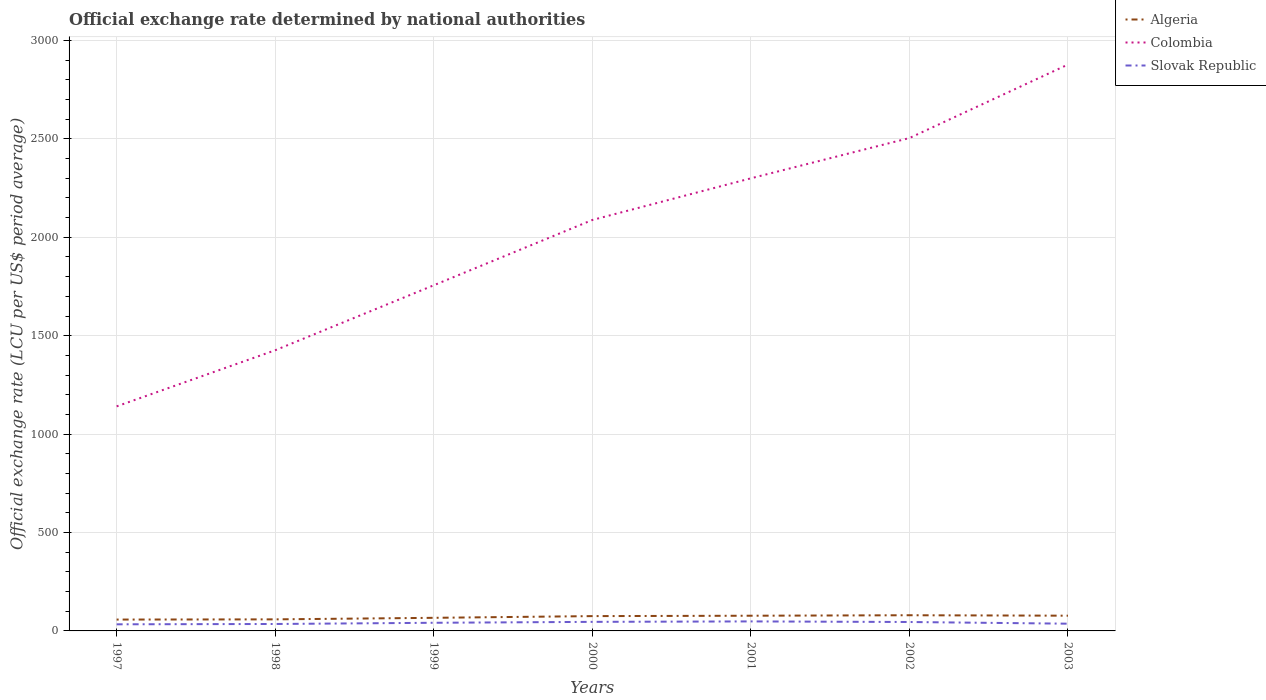Across all years, what is the maximum official exchange rate in Algeria?
Offer a very short reply. 57.71. What is the total official exchange rate in Slovak Republic in the graph?
Make the answer very short. -3.16. What is the difference between the highest and the second highest official exchange rate in Algeria?
Keep it short and to the point. 21.97. What is the difference between the highest and the lowest official exchange rate in Colombia?
Keep it short and to the point. 4. How many lines are there?
Keep it short and to the point. 3. What is the difference between two consecutive major ticks on the Y-axis?
Your response must be concise. 500. Are the values on the major ticks of Y-axis written in scientific E-notation?
Provide a succinct answer. No. Does the graph contain any zero values?
Your answer should be very brief. No. How many legend labels are there?
Offer a very short reply. 3. How are the legend labels stacked?
Make the answer very short. Vertical. What is the title of the graph?
Keep it short and to the point. Official exchange rate determined by national authorities. Does "Dominica" appear as one of the legend labels in the graph?
Offer a terse response. No. What is the label or title of the X-axis?
Your answer should be very brief. Years. What is the label or title of the Y-axis?
Keep it short and to the point. Official exchange rate (LCU per US$ period average). What is the Official exchange rate (LCU per US$ period average) in Algeria in 1997?
Give a very brief answer. 57.71. What is the Official exchange rate (LCU per US$ period average) in Colombia in 1997?
Provide a succinct answer. 1140.96. What is the Official exchange rate (LCU per US$ period average) in Slovak Republic in 1997?
Offer a terse response. 33.62. What is the Official exchange rate (LCU per US$ period average) in Algeria in 1998?
Your answer should be compact. 58.74. What is the Official exchange rate (LCU per US$ period average) of Colombia in 1998?
Offer a terse response. 1426.04. What is the Official exchange rate (LCU per US$ period average) of Slovak Republic in 1998?
Keep it short and to the point. 35.23. What is the Official exchange rate (LCU per US$ period average) of Algeria in 1999?
Your response must be concise. 66.57. What is the Official exchange rate (LCU per US$ period average) in Colombia in 1999?
Offer a very short reply. 1756.23. What is the Official exchange rate (LCU per US$ period average) of Slovak Republic in 1999?
Give a very brief answer. 41.36. What is the Official exchange rate (LCU per US$ period average) in Algeria in 2000?
Provide a short and direct response. 75.26. What is the Official exchange rate (LCU per US$ period average) in Colombia in 2000?
Your answer should be very brief. 2087.9. What is the Official exchange rate (LCU per US$ period average) in Slovak Republic in 2000?
Your answer should be very brief. 46.04. What is the Official exchange rate (LCU per US$ period average) in Algeria in 2001?
Ensure brevity in your answer.  77.22. What is the Official exchange rate (LCU per US$ period average) of Colombia in 2001?
Your answer should be compact. 2299.63. What is the Official exchange rate (LCU per US$ period average) of Slovak Republic in 2001?
Your response must be concise. 48.35. What is the Official exchange rate (LCU per US$ period average) of Algeria in 2002?
Make the answer very short. 79.68. What is the Official exchange rate (LCU per US$ period average) in Colombia in 2002?
Provide a short and direct response. 2504.24. What is the Official exchange rate (LCU per US$ period average) of Slovak Republic in 2002?
Make the answer very short. 45.33. What is the Official exchange rate (LCU per US$ period average) of Algeria in 2003?
Offer a very short reply. 77.39. What is the Official exchange rate (LCU per US$ period average) of Colombia in 2003?
Provide a short and direct response. 2877.65. What is the Official exchange rate (LCU per US$ period average) of Slovak Republic in 2003?
Keep it short and to the point. 36.77. Across all years, what is the maximum Official exchange rate (LCU per US$ period average) in Algeria?
Your answer should be very brief. 79.68. Across all years, what is the maximum Official exchange rate (LCU per US$ period average) in Colombia?
Provide a short and direct response. 2877.65. Across all years, what is the maximum Official exchange rate (LCU per US$ period average) in Slovak Republic?
Provide a succinct answer. 48.35. Across all years, what is the minimum Official exchange rate (LCU per US$ period average) of Algeria?
Make the answer very short. 57.71. Across all years, what is the minimum Official exchange rate (LCU per US$ period average) in Colombia?
Offer a very short reply. 1140.96. Across all years, what is the minimum Official exchange rate (LCU per US$ period average) of Slovak Republic?
Your answer should be very brief. 33.62. What is the total Official exchange rate (LCU per US$ period average) in Algeria in the graph?
Offer a terse response. 492.57. What is the total Official exchange rate (LCU per US$ period average) in Colombia in the graph?
Ensure brevity in your answer.  1.41e+04. What is the total Official exchange rate (LCU per US$ period average) in Slovak Republic in the graph?
Offer a terse response. 286.7. What is the difference between the Official exchange rate (LCU per US$ period average) of Algeria in 1997 and that in 1998?
Your answer should be very brief. -1.03. What is the difference between the Official exchange rate (LCU per US$ period average) of Colombia in 1997 and that in 1998?
Provide a succinct answer. -285.07. What is the difference between the Official exchange rate (LCU per US$ period average) in Slovak Republic in 1997 and that in 1998?
Ensure brevity in your answer.  -1.62. What is the difference between the Official exchange rate (LCU per US$ period average) in Algeria in 1997 and that in 1999?
Make the answer very short. -8.87. What is the difference between the Official exchange rate (LCU per US$ period average) in Colombia in 1997 and that in 1999?
Your answer should be compact. -615.27. What is the difference between the Official exchange rate (LCU per US$ period average) of Slovak Republic in 1997 and that in 1999?
Provide a succinct answer. -7.75. What is the difference between the Official exchange rate (LCU per US$ period average) of Algeria in 1997 and that in 2000?
Offer a very short reply. -17.55. What is the difference between the Official exchange rate (LCU per US$ period average) in Colombia in 1997 and that in 2000?
Your answer should be compact. -946.94. What is the difference between the Official exchange rate (LCU per US$ period average) of Slovak Republic in 1997 and that in 2000?
Keep it short and to the point. -12.42. What is the difference between the Official exchange rate (LCU per US$ period average) in Algeria in 1997 and that in 2001?
Your answer should be compact. -19.51. What is the difference between the Official exchange rate (LCU per US$ period average) of Colombia in 1997 and that in 2001?
Keep it short and to the point. -1158.67. What is the difference between the Official exchange rate (LCU per US$ period average) of Slovak Republic in 1997 and that in 2001?
Offer a very short reply. -14.74. What is the difference between the Official exchange rate (LCU per US$ period average) in Algeria in 1997 and that in 2002?
Offer a very short reply. -21.97. What is the difference between the Official exchange rate (LCU per US$ period average) in Colombia in 1997 and that in 2002?
Your response must be concise. -1363.28. What is the difference between the Official exchange rate (LCU per US$ period average) of Slovak Republic in 1997 and that in 2002?
Your answer should be very brief. -11.71. What is the difference between the Official exchange rate (LCU per US$ period average) of Algeria in 1997 and that in 2003?
Your response must be concise. -19.69. What is the difference between the Official exchange rate (LCU per US$ period average) of Colombia in 1997 and that in 2003?
Offer a very short reply. -1736.69. What is the difference between the Official exchange rate (LCU per US$ period average) in Slovak Republic in 1997 and that in 2003?
Your answer should be compact. -3.16. What is the difference between the Official exchange rate (LCU per US$ period average) of Algeria in 1998 and that in 1999?
Keep it short and to the point. -7.83. What is the difference between the Official exchange rate (LCU per US$ period average) of Colombia in 1998 and that in 1999?
Keep it short and to the point. -330.19. What is the difference between the Official exchange rate (LCU per US$ period average) in Slovak Republic in 1998 and that in 1999?
Give a very brief answer. -6.13. What is the difference between the Official exchange rate (LCU per US$ period average) of Algeria in 1998 and that in 2000?
Your answer should be compact. -16.52. What is the difference between the Official exchange rate (LCU per US$ period average) in Colombia in 1998 and that in 2000?
Offer a terse response. -661.87. What is the difference between the Official exchange rate (LCU per US$ period average) of Slovak Republic in 1998 and that in 2000?
Keep it short and to the point. -10.8. What is the difference between the Official exchange rate (LCU per US$ period average) of Algeria in 1998 and that in 2001?
Keep it short and to the point. -18.48. What is the difference between the Official exchange rate (LCU per US$ period average) of Colombia in 1998 and that in 2001?
Provide a succinct answer. -873.6. What is the difference between the Official exchange rate (LCU per US$ period average) of Slovak Republic in 1998 and that in 2001?
Your answer should be compact. -13.12. What is the difference between the Official exchange rate (LCU per US$ period average) of Algeria in 1998 and that in 2002?
Offer a terse response. -20.94. What is the difference between the Official exchange rate (LCU per US$ period average) in Colombia in 1998 and that in 2002?
Offer a terse response. -1078.2. What is the difference between the Official exchange rate (LCU per US$ period average) of Slovak Republic in 1998 and that in 2002?
Your answer should be very brief. -10.09. What is the difference between the Official exchange rate (LCU per US$ period average) of Algeria in 1998 and that in 2003?
Provide a succinct answer. -18.66. What is the difference between the Official exchange rate (LCU per US$ period average) of Colombia in 1998 and that in 2003?
Ensure brevity in your answer.  -1451.62. What is the difference between the Official exchange rate (LCU per US$ period average) of Slovak Republic in 1998 and that in 2003?
Make the answer very short. -1.54. What is the difference between the Official exchange rate (LCU per US$ period average) in Algeria in 1999 and that in 2000?
Offer a terse response. -8.69. What is the difference between the Official exchange rate (LCU per US$ period average) of Colombia in 1999 and that in 2000?
Provide a short and direct response. -331.67. What is the difference between the Official exchange rate (LCU per US$ period average) in Slovak Republic in 1999 and that in 2000?
Your answer should be very brief. -4.67. What is the difference between the Official exchange rate (LCU per US$ period average) of Algeria in 1999 and that in 2001?
Provide a short and direct response. -10.64. What is the difference between the Official exchange rate (LCU per US$ period average) of Colombia in 1999 and that in 2001?
Make the answer very short. -543.4. What is the difference between the Official exchange rate (LCU per US$ period average) of Slovak Republic in 1999 and that in 2001?
Provide a succinct answer. -6.99. What is the difference between the Official exchange rate (LCU per US$ period average) in Algeria in 1999 and that in 2002?
Ensure brevity in your answer.  -13.11. What is the difference between the Official exchange rate (LCU per US$ period average) of Colombia in 1999 and that in 2002?
Your answer should be very brief. -748.01. What is the difference between the Official exchange rate (LCU per US$ period average) in Slovak Republic in 1999 and that in 2002?
Offer a very short reply. -3.96. What is the difference between the Official exchange rate (LCU per US$ period average) of Algeria in 1999 and that in 2003?
Your answer should be very brief. -10.82. What is the difference between the Official exchange rate (LCU per US$ period average) of Colombia in 1999 and that in 2003?
Offer a very short reply. -1121.42. What is the difference between the Official exchange rate (LCU per US$ period average) of Slovak Republic in 1999 and that in 2003?
Provide a short and direct response. 4.59. What is the difference between the Official exchange rate (LCU per US$ period average) in Algeria in 2000 and that in 2001?
Make the answer very short. -1.96. What is the difference between the Official exchange rate (LCU per US$ period average) in Colombia in 2000 and that in 2001?
Your response must be concise. -211.73. What is the difference between the Official exchange rate (LCU per US$ period average) of Slovak Republic in 2000 and that in 2001?
Provide a short and direct response. -2.32. What is the difference between the Official exchange rate (LCU per US$ period average) in Algeria in 2000 and that in 2002?
Keep it short and to the point. -4.42. What is the difference between the Official exchange rate (LCU per US$ period average) in Colombia in 2000 and that in 2002?
Give a very brief answer. -416.34. What is the difference between the Official exchange rate (LCU per US$ period average) of Slovak Republic in 2000 and that in 2002?
Your response must be concise. 0.71. What is the difference between the Official exchange rate (LCU per US$ period average) of Algeria in 2000 and that in 2003?
Make the answer very short. -2.14. What is the difference between the Official exchange rate (LCU per US$ period average) in Colombia in 2000 and that in 2003?
Your answer should be compact. -789.75. What is the difference between the Official exchange rate (LCU per US$ period average) in Slovak Republic in 2000 and that in 2003?
Your answer should be compact. 9.26. What is the difference between the Official exchange rate (LCU per US$ period average) in Algeria in 2001 and that in 2002?
Your response must be concise. -2.47. What is the difference between the Official exchange rate (LCU per US$ period average) in Colombia in 2001 and that in 2002?
Provide a succinct answer. -204.61. What is the difference between the Official exchange rate (LCU per US$ period average) in Slovak Republic in 2001 and that in 2002?
Keep it short and to the point. 3.03. What is the difference between the Official exchange rate (LCU per US$ period average) of Algeria in 2001 and that in 2003?
Your response must be concise. -0.18. What is the difference between the Official exchange rate (LCU per US$ period average) in Colombia in 2001 and that in 2003?
Provide a short and direct response. -578.02. What is the difference between the Official exchange rate (LCU per US$ period average) of Slovak Republic in 2001 and that in 2003?
Provide a succinct answer. 11.58. What is the difference between the Official exchange rate (LCU per US$ period average) in Algeria in 2002 and that in 2003?
Your answer should be compact. 2.29. What is the difference between the Official exchange rate (LCU per US$ period average) of Colombia in 2002 and that in 2003?
Keep it short and to the point. -373.41. What is the difference between the Official exchange rate (LCU per US$ period average) of Slovak Republic in 2002 and that in 2003?
Your answer should be very brief. 8.55. What is the difference between the Official exchange rate (LCU per US$ period average) in Algeria in 1997 and the Official exchange rate (LCU per US$ period average) in Colombia in 1998?
Your answer should be compact. -1368.33. What is the difference between the Official exchange rate (LCU per US$ period average) in Algeria in 1997 and the Official exchange rate (LCU per US$ period average) in Slovak Republic in 1998?
Make the answer very short. 22.47. What is the difference between the Official exchange rate (LCU per US$ period average) in Colombia in 1997 and the Official exchange rate (LCU per US$ period average) in Slovak Republic in 1998?
Provide a short and direct response. 1105.73. What is the difference between the Official exchange rate (LCU per US$ period average) in Algeria in 1997 and the Official exchange rate (LCU per US$ period average) in Colombia in 1999?
Make the answer very short. -1698.52. What is the difference between the Official exchange rate (LCU per US$ period average) in Algeria in 1997 and the Official exchange rate (LCU per US$ period average) in Slovak Republic in 1999?
Ensure brevity in your answer.  16.34. What is the difference between the Official exchange rate (LCU per US$ period average) in Colombia in 1997 and the Official exchange rate (LCU per US$ period average) in Slovak Republic in 1999?
Ensure brevity in your answer.  1099.6. What is the difference between the Official exchange rate (LCU per US$ period average) of Algeria in 1997 and the Official exchange rate (LCU per US$ period average) of Colombia in 2000?
Your response must be concise. -2030.2. What is the difference between the Official exchange rate (LCU per US$ period average) of Algeria in 1997 and the Official exchange rate (LCU per US$ period average) of Slovak Republic in 2000?
Offer a very short reply. 11.67. What is the difference between the Official exchange rate (LCU per US$ period average) in Colombia in 1997 and the Official exchange rate (LCU per US$ period average) in Slovak Republic in 2000?
Your answer should be very brief. 1094.93. What is the difference between the Official exchange rate (LCU per US$ period average) in Algeria in 1997 and the Official exchange rate (LCU per US$ period average) in Colombia in 2001?
Provide a short and direct response. -2241.93. What is the difference between the Official exchange rate (LCU per US$ period average) of Algeria in 1997 and the Official exchange rate (LCU per US$ period average) of Slovak Republic in 2001?
Make the answer very short. 9.35. What is the difference between the Official exchange rate (LCU per US$ period average) in Colombia in 1997 and the Official exchange rate (LCU per US$ period average) in Slovak Republic in 2001?
Offer a very short reply. 1092.61. What is the difference between the Official exchange rate (LCU per US$ period average) of Algeria in 1997 and the Official exchange rate (LCU per US$ period average) of Colombia in 2002?
Give a very brief answer. -2446.53. What is the difference between the Official exchange rate (LCU per US$ period average) of Algeria in 1997 and the Official exchange rate (LCU per US$ period average) of Slovak Republic in 2002?
Ensure brevity in your answer.  12.38. What is the difference between the Official exchange rate (LCU per US$ period average) in Colombia in 1997 and the Official exchange rate (LCU per US$ period average) in Slovak Republic in 2002?
Your answer should be very brief. 1095.64. What is the difference between the Official exchange rate (LCU per US$ period average) in Algeria in 1997 and the Official exchange rate (LCU per US$ period average) in Colombia in 2003?
Give a very brief answer. -2819.95. What is the difference between the Official exchange rate (LCU per US$ period average) of Algeria in 1997 and the Official exchange rate (LCU per US$ period average) of Slovak Republic in 2003?
Offer a terse response. 20.93. What is the difference between the Official exchange rate (LCU per US$ period average) of Colombia in 1997 and the Official exchange rate (LCU per US$ period average) of Slovak Republic in 2003?
Your answer should be compact. 1104.19. What is the difference between the Official exchange rate (LCU per US$ period average) in Algeria in 1998 and the Official exchange rate (LCU per US$ period average) in Colombia in 1999?
Your answer should be compact. -1697.49. What is the difference between the Official exchange rate (LCU per US$ period average) in Algeria in 1998 and the Official exchange rate (LCU per US$ period average) in Slovak Republic in 1999?
Ensure brevity in your answer.  17.38. What is the difference between the Official exchange rate (LCU per US$ period average) in Colombia in 1998 and the Official exchange rate (LCU per US$ period average) in Slovak Republic in 1999?
Your answer should be compact. 1384.67. What is the difference between the Official exchange rate (LCU per US$ period average) in Algeria in 1998 and the Official exchange rate (LCU per US$ period average) in Colombia in 2000?
Make the answer very short. -2029.16. What is the difference between the Official exchange rate (LCU per US$ period average) in Algeria in 1998 and the Official exchange rate (LCU per US$ period average) in Slovak Republic in 2000?
Ensure brevity in your answer.  12.7. What is the difference between the Official exchange rate (LCU per US$ period average) in Colombia in 1998 and the Official exchange rate (LCU per US$ period average) in Slovak Republic in 2000?
Offer a very short reply. 1380. What is the difference between the Official exchange rate (LCU per US$ period average) of Algeria in 1998 and the Official exchange rate (LCU per US$ period average) of Colombia in 2001?
Provide a succinct answer. -2240.89. What is the difference between the Official exchange rate (LCU per US$ period average) in Algeria in 1998 and the Official exchange rate (LCU per US$ period average) in Slovak Republic in 2001?
Ensure brevity in your answer.  10.38. What is the difference between the Official exchange rate (LCU per US$ period average) in Colombia in 1998 and the Official exchange rate (LCU per US$ period average) in Slovak Republic in 2001?
Provide a short and direct response. 1377.68. What is the difference between the Official exchange rate (LCU per US$ period average) of Algeria in 1998 and the Official exchange rate (LCU per US$ period average) of Colombia in 2002?
Provide a succinct answer. -2445.5. What is the difference between the Official exchange rate (LCU per US$ period average) of Algeria in 1998 and the Official exchange rate (LCU per US$ period average) of Slovak Republic in 2002?
Offer a terse response. 13.41. What is the difference between the Official exchange rate (LCU per US$ period average) of Colombia in 1998 and the Official exchange rate (LCU per US$ period average) of Slovak Republic in 2002?
Offer a terse response. 1380.71. What is the difference between the Official exchange rate (LCU per US$ period average) in Algeria in 1998 and the Official exchange rate (LCU per US$ period average) in Colombia in 2003?
Give a very brief answer. -2818.91. What is the difference between the Official exchange rate (LCU per US$ period average) in Algeria in 1998 and the Official exchange rate (LCU per US$ period average) in Slovak Republic in 2003?
Your answer should be compact. 21.97. What is the difference between the Official exchange rate (LCU per US$ period average) in Colombia in 1998 and the Official exchange rate (LCU per US$ period average) in Slovak Republic in 2003?
Make the answer very short. 1389.26. What is the difference between the Official exchange rate (LCU per US$ period average) in Algeria in 1999 and the Official exchange rate (LCU per US$ period average) in Colombia in 2000?
Offer a terse response. -2021.33. What is the difference between the Official exchange rate (LCU per US$ period average) of Algeria in 1999 and the Official exchange rate (LCU per US$ period average) of Slovak Republic in 2000?
Your answer should be very brief. 20.54. What is the difference between the Official exchange rate (LCU per US$ period average) of Colombia in 1999 and the Official exchange rate (LCU per US$ period average) of Slovak Republic in 2000?
Provide a short and direct response. 1710.2. What is the difference between the Official exchange rate (LCU per US$ period average) in Algeria in 1999 and the Official exchange rate (LCU per US$ period average) in Colombia in 2001?
Keep it short and to the point. -2233.06. What is the difference between the Official exchange rate (LCU per US$ period average) in Algeria in 1999 and the Official exchange rate (LCU per US$ period average) in Slovak Republic in 2001?
Keep it short and to the point. 18.22. What is the difference between the Official exchange rate (LCU per US$ period average) of Colombia in 1999 and the Official exchange rate (LCU per US$ period average) of Slovak Republic in 2001?
Keep it short and to the point. 1707.88. What is the difference between the Official exchange rate (LCU per US$ period average) in Algeria in 1999 and the Official exchange rate (LCU per US$ period average) in Colombia in 2002?
Your answer should be very brief. -2437.67. What is the difference between the Official exchange rate (LCU per US$ period average) in Algeria in 1999 and the Official exchange rate (LCU per US$ period average) in Slovak Republic in 2002?
Your response must be concise. 21.25. What is the difference between the Official exchange rate (LCU per US$ period average) of Colombia in 1999 and the Official exchange rate (LCU per US$ period average) of Slovak Republic in 2002?
Your answer should be very brief. 1710.9. What is the difference between the Official exchange rate (LCU per US$ period average) of Algeria in 1999 and the Official exchange rate (LCU per US$ period average) of Colombia in 2003?
Your response must be concise. -2811.08. What is the difference between the Official exchange rate (LCU per US$ period average) in Algeria in 1999 and the Official exchange rate (LCU per US$ period average) in Slovak Republic in 2003?
Ensure brevity in your answer.  29.8. What is the difference between the Official exchange rate (LCU per US$ period average) of Colombia in 1999 and the Official exchange rate (LCU per US$ period average) of Slovak Republic in 2003?
Your response must be concise. 1719.46. What is the difference between the Official exchange rate (LCU per US$ period average) of Algeria in 2000 and the Official exchange rate (LCU per US$ period average) of Colombia in 2001?
Offer a terse response. -2224.37. What is the difference between the Official exchange rate (LCU per US$ period average) of Algeria in 2000 and the Official exchange rate (LCU per US$ period average) of Slovak Republic in 2001?
Keep it short and to the point. 26.91. What is the difference between the Official exchange rate (LCU per US$ period average) of Colombia in 2000 and the Official exchange rate (LCU per US$ period average) of Slovak Republic in 2001?
Provide a succinct answer. 2039.55. What is the difference between the Official exchange rate (LCU per US$ period average) of Algeria in 2000 and the Official exchange rate (LCU per US$ period average) of Colombia in 2002?
Give a very brief answer. -2428.98. What is the difference between the Official exchange rate (LCU per US$ period average) of Algeria in 2000 and the Official exchange rate (LCU per US$ period average) of Slovak Republic in 2002?
Your answer should be very brief. 29.93. What is the difference between the Official exchange rate (LCU per US$ period average) of Colombia in 2000 and the Official exchange rate (LCU per US$ period average) of Slovak Republic in 2002?
Your answer should be compact. 2042.58. What is the difference between the Official exchange rate (LCU per US$ period average) in Algeria in 2000 and the Official exchange rate (LCU per US$ period average) in Colombia in 2003?
Keep it short and to the point. -2802.39. What is the difference between the Official exchange rate (LCU per US$ period average) of Algeria in 2000 and the Official exchange rate (LCU per US$ period average) of Slovak Republic in 2003?
Offer a terse response. 38.49. What is the difference between the Official exchange rate (LCU per US$ period average) in Colombia in 2000 and the Official exchange rate (LCU per US$ period average) in Slovak Republic in 2003?
Your answer should be compact. 2051.13. What is the difference between the Official exchange rate (LCU per US$ period average) in Algeria in 2001 and the Official exchange rate (LCU per US$ period average) in Colombia in 2002?
Offer a terse response. -2427.03. What is the difference between the Official exchange rate (LCU per US$ period average) of Algeria in 2001 and the Official exchange rate (LCU per US$ period average) of Slovak Republic in 2002?
Your answer should be compact. 31.89. What is the difference between the Official exchange rate (LCU per US$ period average) in Colombia in 2001 and the Official exchange rate (LCU per US$ period average) in Slovak Republic in 2002?
Your answer should be compact. 2254.31. What is the difference between the Official exchange rate (LCU per US$ period average) of Algeria in 2001 and the Official exchange rate (LCU per US$ period average) of Colombia in 2003?
Ensure brevity in your answer.  -2800.44. What is the difference between the Official exchange rate (LCU per US$ period average) in Algeria in 2001 and the Official exchange rate (LCU per US$ period average) in Slovak Republic in 2003?
Your answer should be very brief. 40.44. What is the difference between the Official exchange rate (LCU per US$ period average) in Colombia in 2001 and the Official exchange rate (LCU per US$ period average) in Slovak Republic in 2003?
Give a very brief answer. 2262.86. What is the difference between the Official exchange rate (LCU per US$ period average) of Algeria in 2002 and the Official exchange rate (LCU per US$ period average) of Colombia in 2003?
Your answer should be compact. -2797.97. What is the difference between the Official exchange rate (LCU per US$ period average) of Algeria in 2002 and the Official exchange rate (LCU per US$ period average) of Slovak Republic in 2003?
Keep it short and to the point. 42.91. What is the difference between the Official exchange rate (LCU per US$ period average) in Colombia in 2002 and the Official exchange rate (LCU per US$ period average) in Slovak Republic in 2003?
Give a very brief answer. 2467.47. What is the average Official exchange rate (LCU per US$ period average) of Algeria per year?
Your answer should be compact. 70.37. What is the average Official exchange rate (LCU per US$ period average) of Colombia per year?
Give a very brief answer. 2013.24. What is the average Official exchange rate (LCU per US$ period average) of Slovak Republic per year?
Your answer should be compact. 40.96. In the year 1997, what is the difference between the Official exchange rate (LCU per US$ period average) of Algeria and Official exchange rate (LCU per US$ period average) of Colombia?
Give a very brief answer. -1083.26. In the year 1997, what is the difference between the Official exchange rate (LCU per US$ period average) of Algeria and Official exchange rate (LCU per US$ period average) of Slovak Republic?
Provide a short and direct response. 24.09. In the year 1997, what is the difference between the Official exchange rate (LCU per US$ period average) in Colombia and Official exchange rate (LCU per US$ period average) in Slovak Republic?
Ensure brevity in your answer.  1107.35. In the year 1998, what is the difference between the Official exchange rate (LCU per US$ period average) in Algeria and Official exchange rate (LCU per US$ period average) in Colombia?
Provide a short and direct response. -1367.3. In the year 1998, what is the difference between the Official exchange rate (LCU per US$ period average) in Algeria and Official exchange rate (LCU per US$ period average) in Slovak Republic?
Your answer should be compact. 23.51. In the year 1998, what is the difference between the Official exchange rate (LCU per US$ period average) of Colombia and Official exchange rate (LCU per US$ period average) of Slovak Republic?
Provide a short and direct response. 1390.8. In the year 1999, what is the difference between the Official exchange rate (LCU per US$ period average) of Algeria and Official exchange rate (LCU per US$ period average) of Colombia?
Give a very brief answer. -1689.66. In the year 1999, what is the difference between the Official exchange rate (LCU per US$ period average) of Algeria and Official exchange rate (LCU per US$ period average) of Slovak Republic?
Your answer should be compact. 25.21. In the year 1999, what is the difference between the Official exchange rate (LCU per US$ period average) in Colombia and Official exchange rate (LCU per US$ period average) in Slovak Republic?
Keep it short and to the point. 1714.87. In the year 2000, what is the difference between the Official exchange rate (LCU per US$ period average) of Algeria and Official exchange rate (LCU per US$ period average) of Colombia?
Your response must be concise. -2012.64. In the year 2000, what is the difference between the Official exchange rate (LCU per US$ period average) in Algeria and Official exchange rate (LCU per US$ period average) in Slovak Republic?
Keep it short and to the point. 29.22. In the year 2000, what is the difference between the Official exchange rate (LCU per US$ period average) in Colombia and Official exchange rate (LCU per US$ period average) in Slovak Republic?
Your answer should be compact. 2041.87. In the year 2001, what is the difference between the Official exchange rate (LCU per US$ period average) in Algeria and Official exchange rate (LCU per US$ period average) in Colombia?
Provide a short and direct response. -2222.42. In the year 2001, what is the difference between the Official exchange rate (LCU per US$ period average) of Algeria and Official exchange rate (LCU per US$ period average) of Slovak Republic?
Provide a succinct answer. 28.86. In the year 2001, what is the difference between the Official exchange rate (LCU per US$ period average) of Colombia and Official exchange rate (LCU per US$ period average) of Slovak Republic?
Offer a very short reply. 2251.28. In the year 2002, what is the difference between the Official exchange rate (LCU per US$ period average) of Algeria and Official exchange rate (LCU per US$ period average) of Colombia?
Keep it short and to the point. -2424.56. In the year 2002, what is the difference between the Official exchange rate (LCU per US$ period average) in Algeria and Official exchange rate (LCU per US$ period average) in Slovak Republic?
Your answer should be very brief. 34.36. In the year 2002, what is the difference between the Official exchange rate (LCU per US$ period average) of Colombia and Official exchange rate (LCU per US$ period average) of Slovak Republic?
Keep it short and to the point. 2458.91. In the year 2003, what is the difference between the Official exchange rate (LCU per US$ period average) of Algeria and Official exchange rate (LCU per US$ period average) of Colombia?
Make the answer very short. -2800.26. In the year 2003, what is the difference between the Official exchange rate (LCU per US$ period average) in Algeria and Official exchange rate (LCU per US$ period average) in Slovak Republic?
Provide a short and direct response. 40.62. In the year 2003, what is the difference between the Official exchange rate (LCU per US$ period average) in Colombia and Official exchange rate (LCU per US$ period average) in Slovak Republic?
Give a very brief answer. 2840.88. What is the ratio of the Official exchange rate (LCU per US$ period average) in Algeria in 1997 to that in 1998?
Your answer should be very brief. 0.98. What is the ratio of the Official exchange rate (LCU per US$ period average) in Colombia in 1997 to that in 1998?
Your answer should be very brief. 0.8. What is the ratio of the Official exchange rate (LCU per US$ period average) of Slovak Republic in 1997 to that in 1998?
Provide a short and direct response. 0.95. What is the ratio of the Official exchange rate (LCU per US$ period average) of Algeria in 1997 to that in 1999?
Ensure brevity in your answer.  0.87. What is the ratio of the Official exchange rate (LCU per US$ period average) in Colombia in 1997 to that in 1999?
Keep it short and to the point. 0.65. What is the ratio of the Official exchange rate (LCU per US$ period average) of Slovak Republic in 1997 to that in 1999?
Your answer should be very brief. 0.81. What is the ratio of the Official exchange rate (LCU per US$ period average) of Algeria in 1997 to that in 2000?
Give a very brief answer. 0.77. What is the ratio of the Official exchange rate (LCU per US$ period average) of Colombia in 1997 to that in 2000?
Your answer should be compact. 0.55. What is the ratio of the Official exchange rate (LCU per US$ period average) in Slovak Republic in 1997 to that in 2000?
Offer a terse response. 0.73. What is the ratio of the Official exchange rate (LCU per US$ period average) of Algeria in 1997 to that in 2001?
Offer a very short reply. 0.75. What is the ratio of the Official exchange rate (LCU per US$ period average) in Colombia in 1997 to that in 2001?
Keep it short and to the point. 0.5. What is the ratio of the Official exchange rate (LCU per US$ period average) of Slovak Republic in 1997 to that in 2001?
Ensure brevity in your answer.  0.7. What is the ratio of the Official exchange rate (LCU per US$ period average) in Algeria in 1997 to that in 2002?
Your response must be concise. 0.72. What is the ratio of the Official exchange rate (LCU per US$ period average) in Colombia in 1997 to that in 2002?
Offer a terse response. 0.46. What is the ratio of the Official exchange rate (LCU per US$ period average) of Slovak Republic in 1997 to that in 2002?
Your response must be concise. 0.74. What is the ratio of the Official exchange rate (LCU per US$ period average) of Algeria in 1997 to that in 2003?
Your answer should be compact. 0.75. What is the ratio of the Official exchange rate (LCU per US$ period average) of Colombia in 1997 to that in 2003?
Give a very brief answer. 0.4. What is the ratio of the Official exchange rate (LCU per US$ period average) in Slovak Republic in 1997 to that in 2003?
Provide a succinct answer. 0.91. What is the ratio of the Official exchange rate (LCU per US$ period average) of Algeria in 1998 to that in 1999?
Make the answer very short. 0.88. What is the ratio of the Official exchange rate (LCU per US$ period average) of Colombia in 1998 to that in 1999?
Keep it short and to the point. 0.81. What is the ratio of the Official exchange rate (LCU per US$ period average) in Slovak Republic in 1998 to that in 1999?
Provide a succinct answer. 0.85. What is the ratio of the Official exchange rate (LCU per US$ period average) in Algeria in 1998 to that in 2000?
Give a very brief answer. 0.78. What is the ratio of the Official exchange rate (LCU per US$ period average) of Colombia in 1998 to that in 2000?
Provide a succinct answer. 0.68. What is the ratio of the Official exchange rate (LCU per US$ period average) of Slovak Republic in 1998 to that in 2000?
Provide a succinct answer. 0.77. What is the ratio of the Official exchange rate (LCU per US$ period average) of Algeria in 1998 to that in 2001?
Offer a very short reply. 0.76. What is the ratio of the Official exchange rate (LCU per US$ period average) of Colombia in 1998 to that in 2001?
Give a very brief answer. 0.62. What is the ratio of the Official exchange rate (LCU per US$ period average) of Slovak Republic in 1998 to that in 2001?
Ensure brevity in your answer.  0.73. What is the ratio of the Official exchange rate (LCU per US$ period average) in Algeria in 1998 to that in 2002?
Offer a terse response. 0.74. What is the ratio of the Official exchange rate (LCU per US$ period average) in Colombia in 1998 to that in 2002?
Ensure brevity in your answer.  0.57. What is the ratio of the Official exchange rate (LCU per US$ period average) in Slovak Republic in 1998 to that in 2002?
Your response must be concise. 0.78. What is the ratio of the Official exchange rate (LCU per US$ period average) of Algeria in 1998 to that in 2003?
Your answer should be very brief. 0.76. What is the ratio of the Official exchange rate (LCU per US$ period average) in Colombia in 1998 to that in 2003?
Provide a short and direct response. 0.5. What is the ratio of the Official exchange rate (LCU per US$ period average) in Slovak Republic in 1998 to that in 2003?
Provide a short and direct response. 0.96. What is the ratio of the Official exchange rate (LCU per US$ period average) of Algeria in 1999 to that in 2000?
Offer a very short reply. 0.88. What is the ratio of the Official exchange rate (LCU per US$ period average) of Colombia in 1999 to that in 2000?
Offer a very short reply. 0.84. What is the ratio of the Official exchange rate (LCU per US$ period average) of Slovak Republic in 1999 to that in 2000?
Your response must be concise. 0.9. What is the ratio of the Official exchange rate (LCU per US$ period average) in Algeria in 1999 to that in 2001?
Offer a terse response. 0.86. What is the ratio of the Official exchange rate (LCU per US$ period average) of Colombia in 1999 to that in 2001?
Your answer should be very brief. 0.76. What is the ratio of the Official exchange rate (LCU per US$ period average) of Slovak Republic in 1999 to that in 2001?
Your answer should be compact. 0.86. What is the ratio of the Official exchange rate (LCU per US$ period average) in Algeria in 1999 to that in 2002?
Your answer should be very brief. 0.84. What is the ratio of the Official exchange rate (LCU per US$ period average) in Colombia in 1999 to that in 2002?
Give a very brief answer. 0.7. What is the ratio of the Official exchange rate (LCU per US$ period average) in Slovak Republic in 1999 to that in 2002?
Ensure brevity in your answer.  0.91. What is the ratio of the Official exchange rate (LCU per US$ period average) in Algeria in 1999 to that in 2003?
Offer a very short reply. 0.86. What is the ratio of the Official exchange rate (LCU per US$ period average) of Colombia in 1999 to that in 2003?
Your answer should be compact. 0.61. What is the ratio of the Official exchange rate (LCU per US$ period average) of Slovak Republic in 1999 to that in 2003?
Your answer should be very brief. 1.12. What is the ratio of the Official exchange rate (LCU per US$ period average) of Algeria in 2000 to that in 2001?
Provide a succinct answer. 0.97. What is the ratio of the Official exchange rate (LCU per US$ period average) of Colombia in 2000 to that in 2001?
Give a very brief answer. 0.91. What is the ratio of the Official exchange rate (LCU per US$ period average) of Slovak Republic in 2000 to that in 2001?
Give a very brief answer. 0.95. What is the ratio of the Official exchange rate (LCU per US$ period average) of Algeria in 2000 to that in 2002?
Your answer should be compact. 0.94. What is the ratio of the Official exchange rate (LCU per US$ period average) in Colombia in 2000 to that in 2002?
Make the answer very short. 0.83. What is the ratio of the Official exchange rate (LCU per US$ period average) of Slovak Republic in 2000 to that in 2002?
Provide a succinct answer. 1.02. What is the ratio of the Official exchange rate (LCU per US$ period average) of Algeria in 2000 to that in 2003?
Offer a very short reply. 0.97. What is the ratio of the Official exchange rate (LCU per US$ period average) in Colombia in 2000 to that in 2003?
Offer a very short reply. 0.73. What is the ratio of the Official exchange rate (LCU per US$ period average) of Slovak Republic in 2000 to that in 2003?
Provide a succinct answer. 1.25. What is the ratio of the Official exchange rate (LCU per US$ period average) in Colombia in 2001 to that in 2002?
Ensure brevity in your answer.  0.92. What is the ratio of the Official exchange rate (LCU per US$ period average) in Slovak Republic in 2001 to that in 2002?
Your response must be concise. 1.07. What is the ratio of the Official exchange rate (LCU per US$ period average) in Algeria in 2001 to that in 2003?
Make the answer very short. 1. What is the ratio of the Official exchange rate (LCU per US$ period average) in Colombia in 2001 to that in 2003?
Your response must be concise. 0.8. What is the ratio of the Official exchange rate (LCU per US$ period average) of Slovak Republic in 2001 to that in 2003?
Your response must be concise. 1.31. What is the ratio of the Official exchange rate (LCU per US$ period average) of Algeria in 2002 to that in 2003?
Provide a short and direct response. 1.03. What is the ratio of the Official exchange rate (LCU per US$ period average) in Colombia in 2002 to that in 2003?
Offer a terse response. 0.87. What is the ratio of the Official exchange rate (LCU per US$ period average) in Slovak Republic in 2002 to that in 2003?
Your answer should be very brief. 1.23. What is the difference between the highest and the second highest Official exchange rate (LCU per US$ period average) in Algeria?
Provide a short and direct response. 2.29. What is the difference between the highest and the second highest Official exchange rate (LCU per US$ period average) in Colombia?
Ensure brevity in your answer.  373.41. What is the difference between the highest and the second highest Official exchange rate (LCU per US$ period average) in Slovak Republic?
Give a very brief answer. 2.32. What is the difference between the highest and the lowest Official exchange rate (LCU per US$ period average) in Algeria?
Offer a terse response. 21.97. What is the difference between the highest and the lowest Official exchange rate (LCU per US$ period average) of Colombia?
Ensure brevity in your answer.  1736.69. What is the difference between the highest and the lowest Official exchange rate (LCU per US$ period average) of Slovak Republic?
Your answer should be very brief. 14.74. 